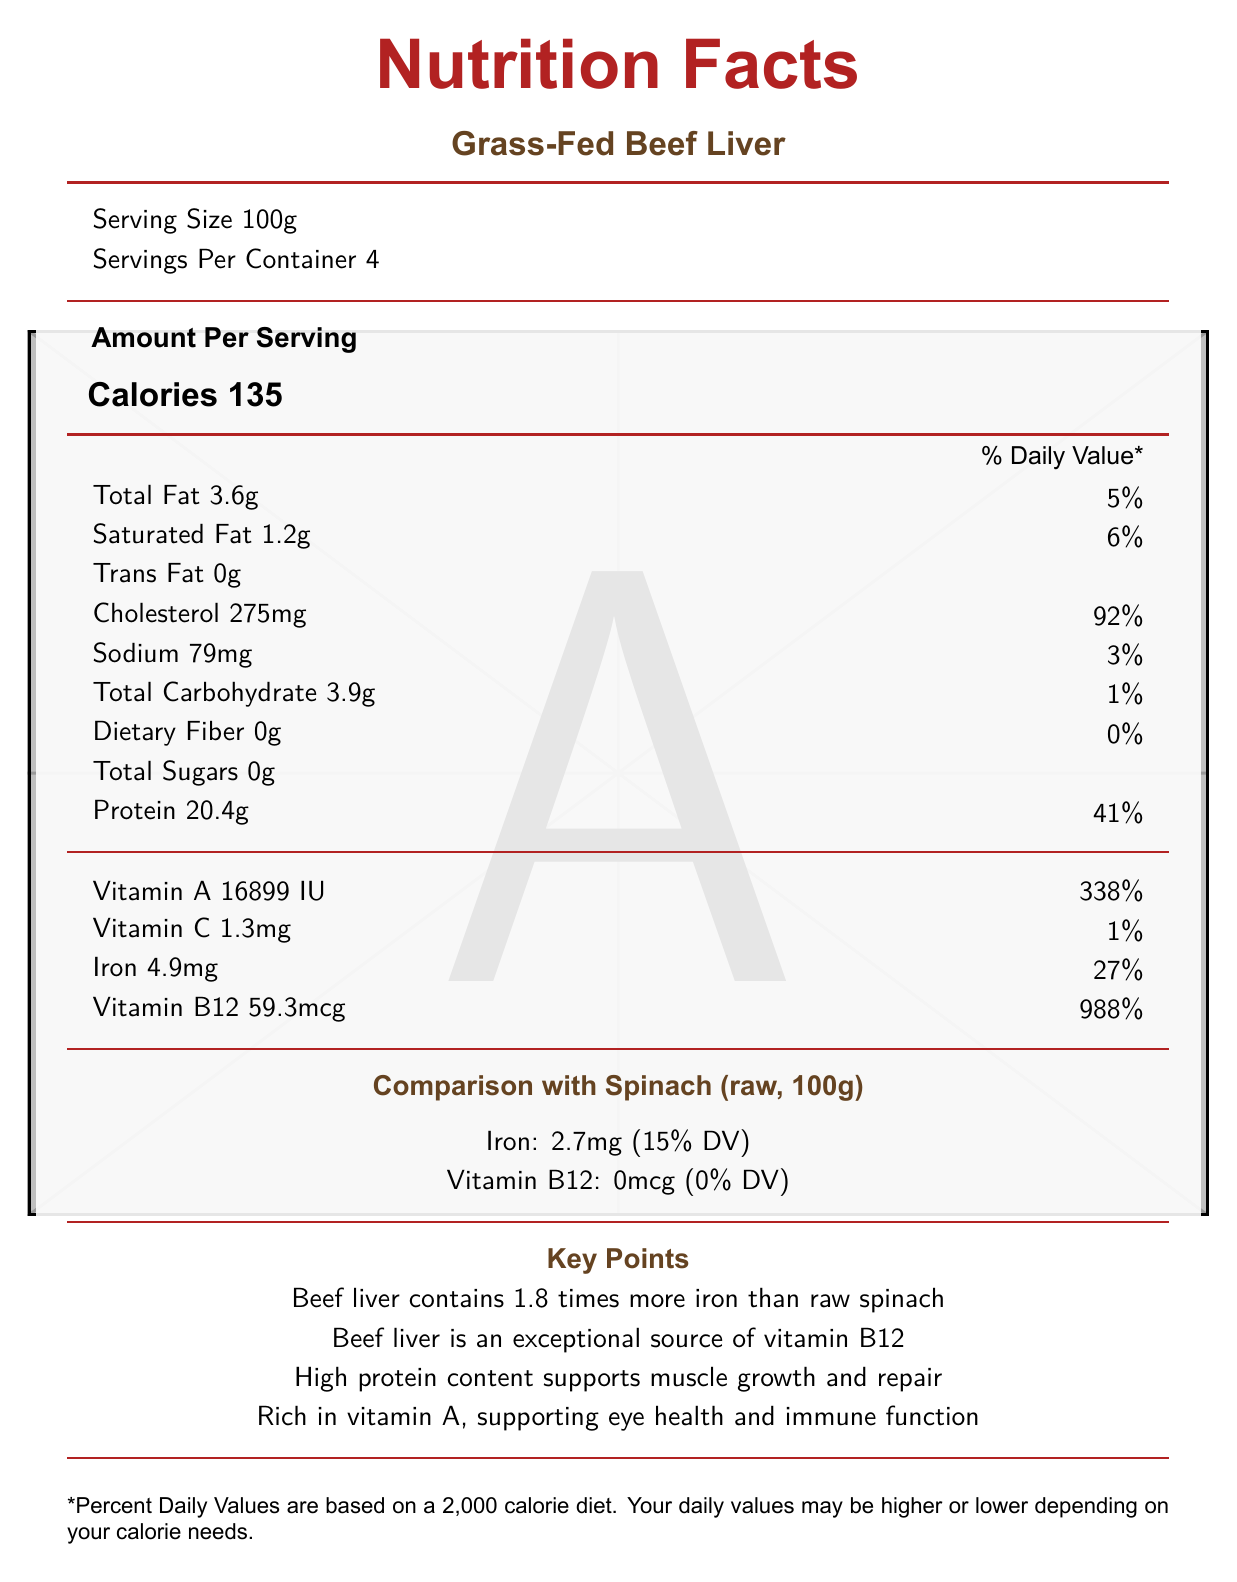What is the serving size for Grass-Fed Beef Liver? The document specifies that the serving size for Grass-Fed Beef Liver is 100 grams.
Answer: 100g How much iron does Grass-Fed Beef Liver contain per serving? The nutritional information lists iron content as 4.9 mg per serving.
Answer: 4.9mg What percentage of the daily value of Vitamin B12 does a serving of Beef Liver provide? The document states that Beef Liver provides 988% of the daily value for Vitamin B12 per serving.
Answer: 988% Which nutrient in Grass-Fed Beef Liver supports muscle growth and repair? The key points mention that the high protein content in Beef Liver supports muscle growth and repair.
Answer: Protein Compare the iron content between Beef Liver and Spinach. The key points section notes that Beef Liver contains 1.8 times more iron than raw spinach.
Answer: Beef Liver has 1.8 times more iron than Spinach. How many calories are in a serving of Grass-Fed Beef Liver? A. 100 B. 120 C. 135 D. 150 The document shows that one serving of Grass-Fed Beef Liver contains 135 calories.
Answer: C. 135 Which of the following vitamins has a higher daily value percentage in Beef Liver compared to Spinach? A. Vitamin A B. Vitamin B12 C. Iron D. Vitamin C Beef Liver provides 988% DV of Vitamin B12, while Spinach has 0% DV, as per the comparison section.
Answer: B. Vitamin B12 Does Beef Liver contain any trans fat? The nutritional information specifies that Beef Liver contains 0 grams of trans fat.
Answer: No Is Beef Liver a good source of Vitamin C? The document shows Beef Liver only has 1% of the daily value for Vitamin C.
Answer: No Summarize the main health benefits highlighted for Beef Liver in this document. The document emphasizes Beef Liver’s higher iron content compared to spinach, exceptional Vitamin B12 levels, muscle-supporting protein, and Vitamin A's benefits for eye and immune health.
Answer: Beef Liver is portrayed as nutritionally dense, superior to plant-based alternatives in iron and Vitamin B12 content, high in protein which supports muscle growth, and rich in Vitamin A which is essential for eye health and immune function. What is the total fat content per serving? The document states the total fat content as 3.6 grams per serving.
Answer: 3.6g What percentage of the daily value of cholesterol does Beef Liver provide? The nutritional information indicates that Beef Liver provides 92% of the daily value for cholesterol per serving.
Answer: 92% How much sodium is in a serving of Grass-Fed Beef Liver? The document lists the sodium content as 79 mg per serving.
Answer: 79mg How many servings per container are there for Grass-Fed Beef Liver? The document specifies that there are 4 servings per container.
Answer: 4 Which product contains Vitamin B12 when comparing Beef Liver and Spinach? The document highlights that Beef Liver has Vitamin B12 while Spinach has 0 mcg per serving.
Answer: Beef Liver Why is Beef Liver considered an exceptional source of Vitamin B12? A. It has no carbohydrates B. It supports eye health C. It contains 59.3mcg per serving D. It is low in cholesterol The document states that Beef Liver contains 59.3 mcg of Vitamin B12 per serving, which is 988% of the daily value.
Answer: C. It contains 59.3mcg per serving Can the presence of dietary fiber in Beef Liver be determined from the document? The document lists dietary fiber content as 0g.
Answer: Yes How much Vitamin A is in Grass-Fed Beef Liver? The document shows that Grass-Fed Beef Liver contains 16899 IU of Vitamin A.
Answer: 16899 IU Compare the calorie content of Beef Liver to another food item not listed in the document. The document only provides the calorie content for Beef Liver and does not include information about other food items for comparison.
Answer: Not enough information 